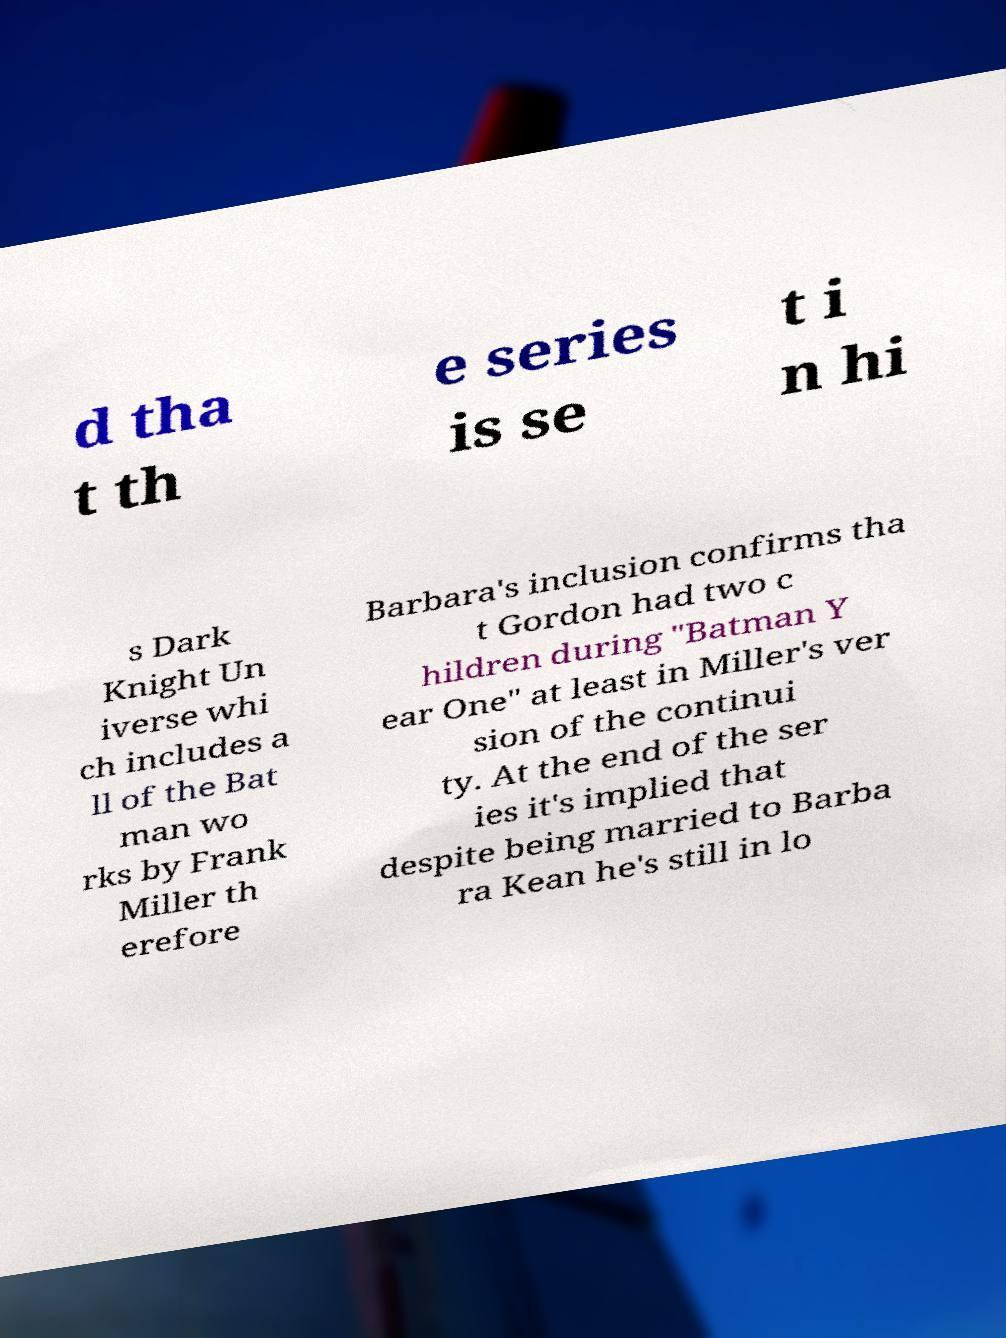Please identify and transcribe the text found in this image. d tha t th e series is se t i n hi s Dark Knight Un iverse whi ch includes a ll of the Bat man wo rks by Frank Miller th erefore Barbara's inclusion confirms tha t Gordon had two c hildren during "Batman Y ear One" at least in Miller's ver sion of the continui ty. At the end of the ser ies it's implied that despite being married to Barba ra Kean he's still in lo 